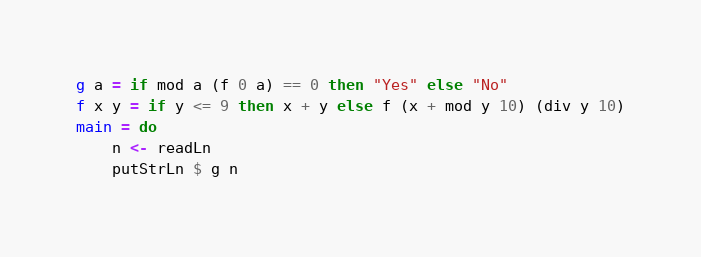<code> <loc_0><loc_0><loc_500><loc_500><_Haskell_>g a = if mod a (f 0 a) == 0 then "Yes" else "No"
f x y = if y <= 9 then x + y else f (x + mod y 10) (div y 10)
main = do
    n <- readLn
    putStrLn $ g n</code> 